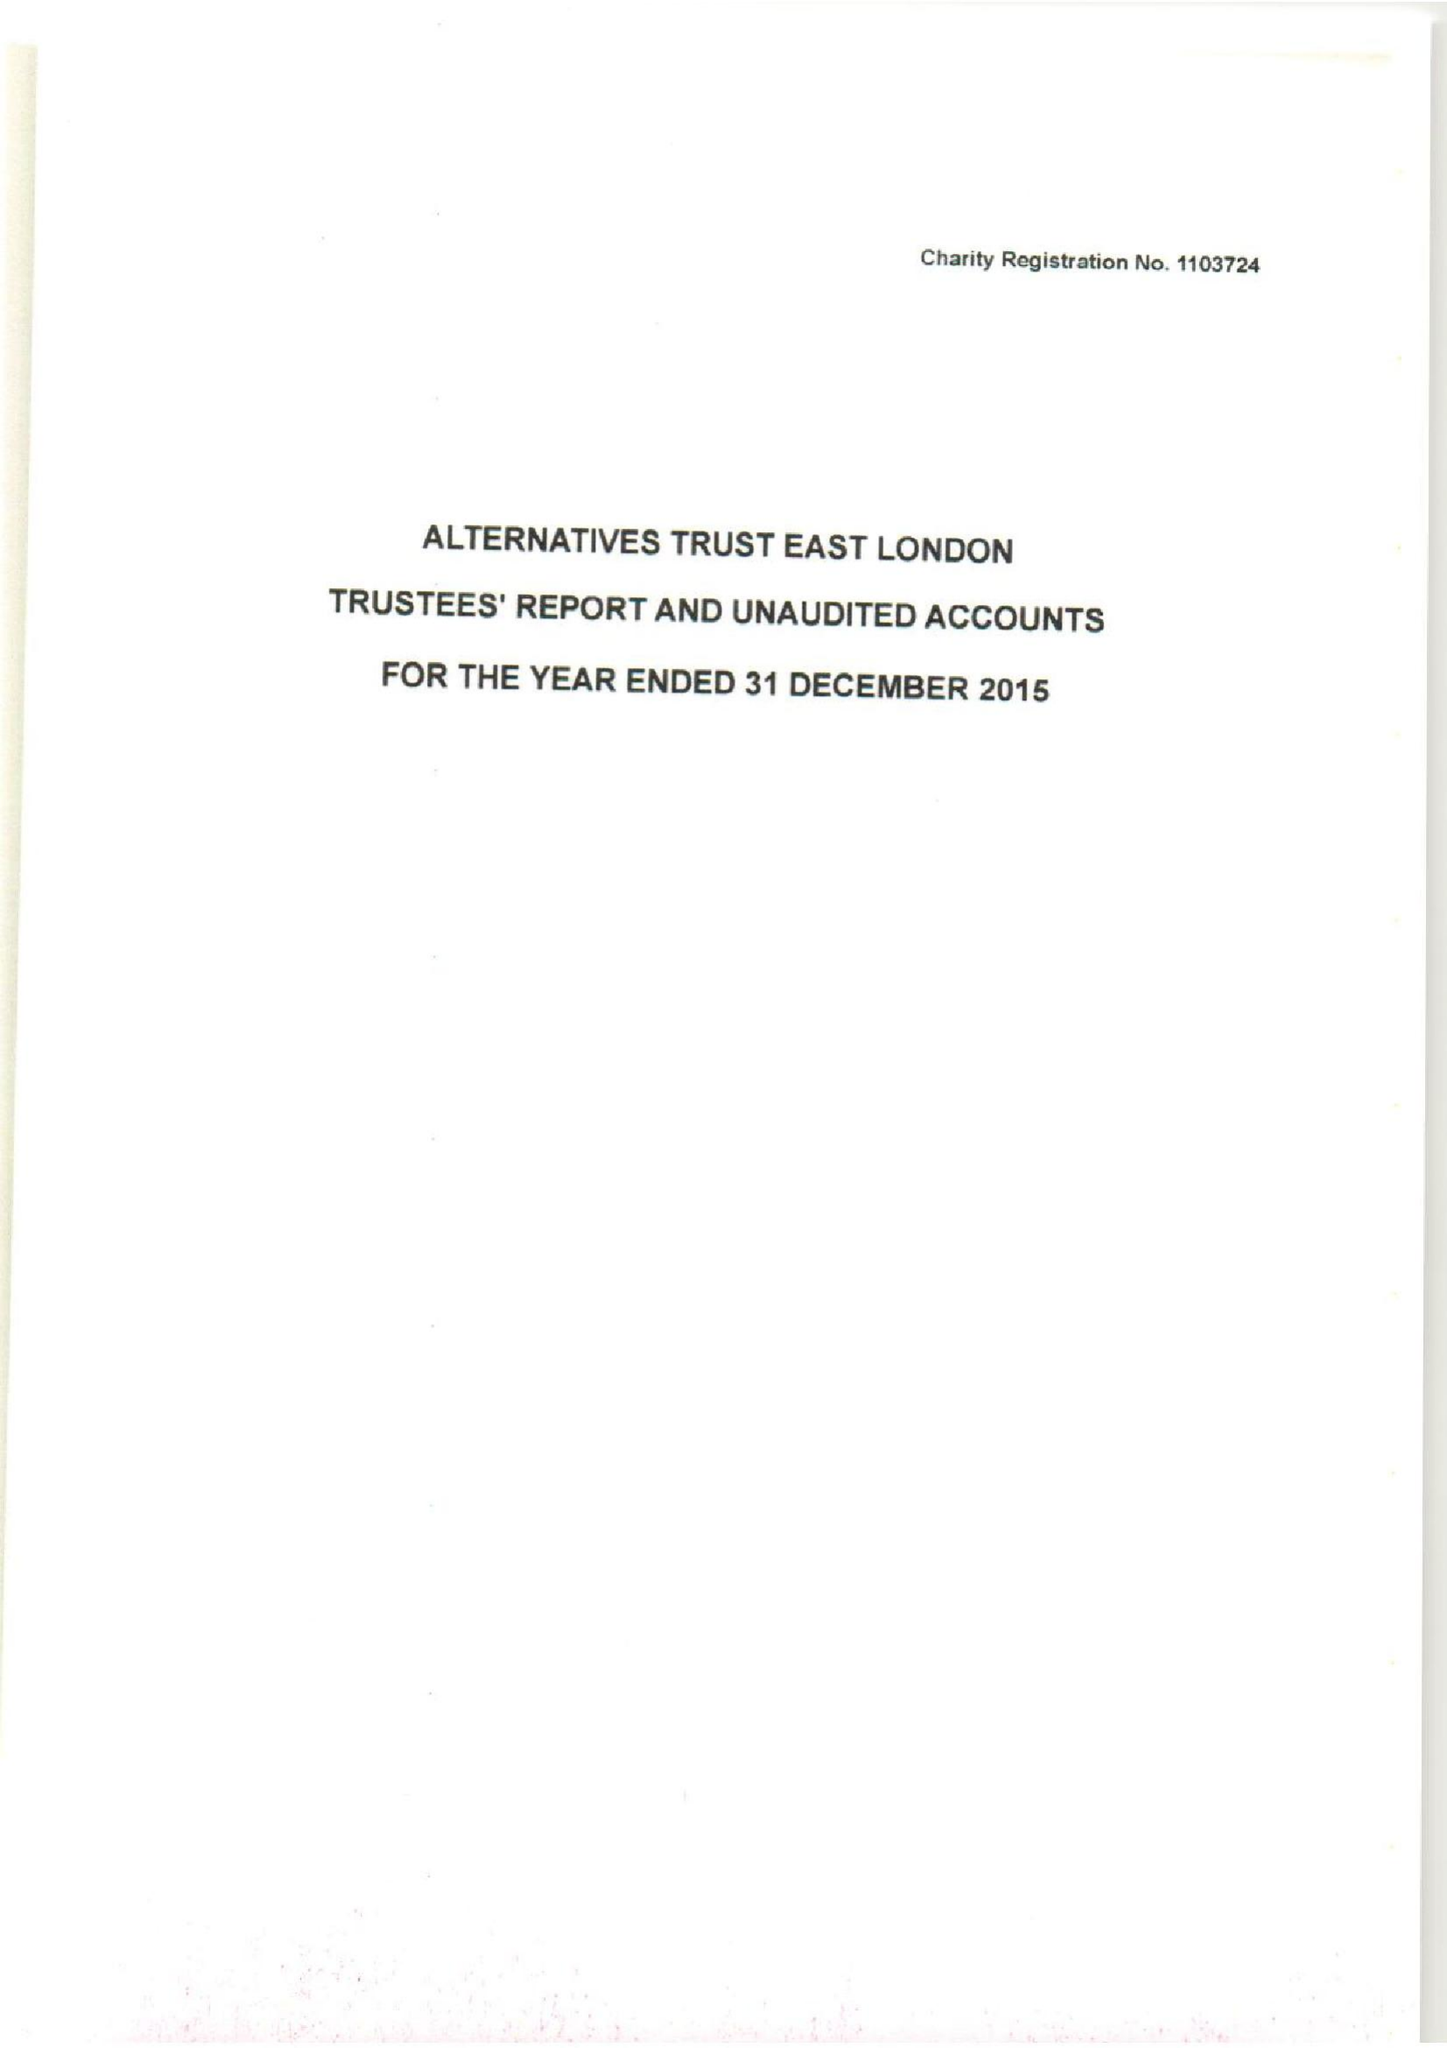What is the value for the income_annually_in_british_pounds?
Answer the question using a single word or phrase. 148041.00 